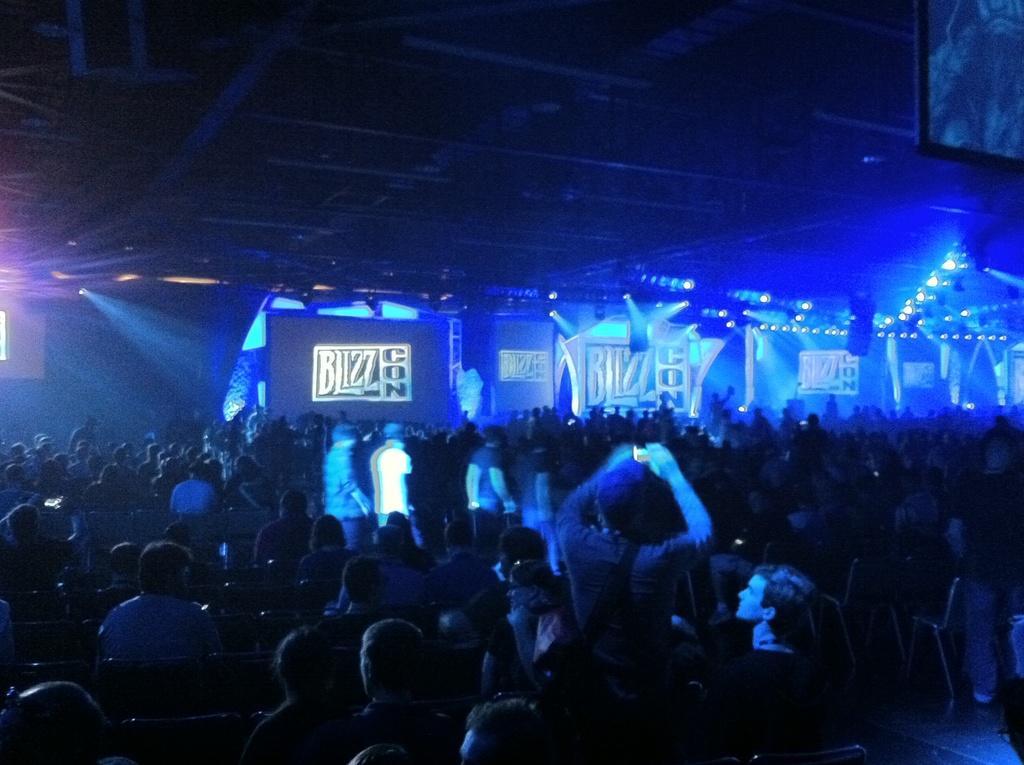Describe this image in one or two sentences. In this picture I can see few people standing and few are seated and I can see a man holding a camera in his hand and I can see few lights to the ceiling and few advertisement boards with some text. 